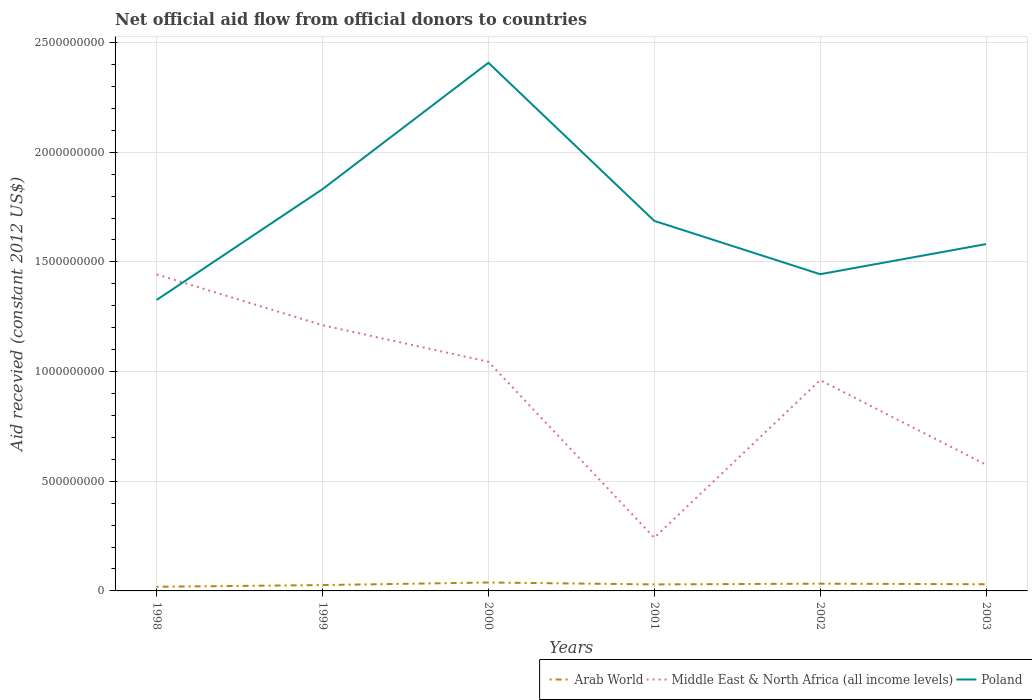How many different coloured lines are there?
Keep it short and to the point. 3. Does the line corresponding to Poland intersect with the line corresponding to Middle East & North Africa (all income levels)?
Keep it short and to the point. Yes. Is the number of lines equal to the number of legend labels?
Provide a short and direct response. Yes. Across all years, what is the maximum total aid received in Middle East & North Africa (all income levels)?
Give a very brief answer. 2.43e+08. What is the total total aid received in Poland in the graph?
Your response must be concise. 2.51e+08. What is the difference between the highest and the second highest total aid received in Arab World?
Your response must be concise. 1.94e+07. What is the difference between the highest and the lowest total aid received in Middle East & North Africa (all income levels)?
Offer a terse response. 4. Is the total aid received in Arab World strictly greater than the total aid received in Poland over the years?
Offer a terse response. Yes. How many lines are there?
Ensure brevity in your answer.  3. How many years are there in the graph?
Your answer should be very brief. 6. Are the values on the major ticks of Y-axis written in scientific E-notation?
Keep it short and to the point. No. Does the graph contain any zero values?
Offer a terse response. No. What is the title of the graph?
Your response must be concise. Net official aid flow from official donors to countries. Does "Denmark" appear as one of the legend labels in the graph?
Provide a succinct answer. No. What is the label or title of the Y-axis?
Give a very brief answer. Aid recevied (constant 2012 US$). What is the Aid recevied (constant 2012 US$) of Arab World in 1998?
Provide a short and direct response. 1.90e+07. What is the Aid recevied (constant 2012 US$) in Middle East & North Africa (all income levels) in 1998?
Provide a short and direct response. 1.44e+09. What is the Aid recevied (constant 2012 US$) of Poland in 1998?
Offer a very short reply. 1.33e+09. What is the Aid recevied (constant 2012 US$) of Arab World in 1999?
Keep it short and to the point. 2.67e+07. What is the Aid recevied (constant 2012 US$) of Middle East & North Africa (all income levels) in 1999?
Your answer should be very brief. 1.21e+09. What is the Aid recevied (constant 2012 US$) in Poland in 1999?
Provide a succinct answer. 1.83e+09. What is the Aid recevied (constant 2012 US$) of Arab World in 2000?
Your answer should be compact. 3.84e+07. What is the Aid recevied (constant 2012 US$) of Middle East & North Africa (all income levels) in 2000?
Offer a very short reply. 1.04e+09. What is the Aid recevied (constant 2012 US$) of Poland in 2000?
Offer a terse response. 2.41e+09. What is the Aid recevied (constant 2012 US$) in Arab World in 2001?
Your answer should be very brief. 2.97e+07. What is the Aid recevied (constant 2012 US$) in Middle East & North Africa (all income levels) in 2001?
Offer a terse response. 2.43e+08. What is the Aid recevied (constant 2012 US$) of Poland in 2001?
Ensure brevity in your answer.  1.69e+09. What is the Aid recevied (constant 2012 US$) of Arab World in 2002?
Ensure brevity in your answer.  3.30e+07. What is the Aid recevied (constant 2012 US$) of Middle East & North Africa (all income levels) in 2002?
Provide a short and direct response. 9.61e+08. What is the Aid recevied (constant 2012 US$) in Poland in 2002?
Your answer should be compact. 1.44e+09. What is the Aid recevied (constant 2012 US$) in Arab World in 2003?
Give a very brief answer. 3.05e+07. What is the Aid recevied (constant 2012 US$) of Middle East & North Africa (all income levels) in 2003?
Keep it short and to the point. 5.75e+08. What is the Aid recevied (constant 2012 US$) in Poland in 2003?
Offer a very short reply. 1.58e+09. Across all years, what is the maximum Aid recevied (constant 2012 US$) of Arab World?
Your answer should be very brief. 3.84e+07. Across all years, what is the maximum Aid recevied (constant 2012 US$) of Middle East & North Africa (all income levels)?
Provide a short and direct response. 1.44e+09. Across all years, what is the maximum Aid recevied (constant 2012 US$) of Poland?
Offer a terse response. 2.41e+09. Across all years, what is the minimum Aid recevied (constant 2012 US$) in Arab World?
Ensure brevity in your answer.  1.90e+07. Across all years, what is the minimum Aid recevied (constant 2012 US$) of Middle East & North Africa (all income levels)?
Your answer should be very brief. 2.43e+08. Across all years, what is the minimum Aid recevied (constant 2012 US$) of Poland?
Make the answer very short. 1.33e+09. What is the total Aid recevied (constant 2012 US$) of Arab World in the graph?
Offer a terse response. 1.77e+08. What is the total Aid recevied (constant 2012 US$) in Middle East & North Africa (all income levels) in the graph?
Keep it short and to the point. 5.48e+09. What is the total Aid recevied (constant 2012 US$) in Poland in the graph?
Your answer should be very brief. 1.03e+1. What is the difference between the Aid recevied (constant 2012 US$) in Arab World in 1998 and that in 1999?
Keep it short and to the point. -7.71e+06. What is the difference between the Aid recevied (constant 2012 US$) in Middle East & North Africa (all income levels) in 1998 and that in 1999?
Keep it short and to the point. 2.32e+08. What is the difference between the Aid recevied (constant 2012 US$) in Poland in 1998 and that in 1999?
Provide a succinct answer. -5.05e+08. What is the difference between the Aid recevied (constant 2012 US$) in Arab World in 1998 and that in 2000?
Give a very brief answer. -1.94e+07. What is the difference between the Aid recevied (constant 2012 US$) in Middle East & North Africa (all income levels) in 1998 and that in 2000?
Your answer should be compact. 3.98e+08. What is the difference between the Aid recevied (constant 2012 US$) in Poland in 1998 and that in 2000?
Provide a succinct answer. -1.08e+09. What is the difference between the Aid recevied (constant 2012 US$) in Arab World in 1998 and that in 2001?
Give a very brief answer. -1.07e+07. What is the difference between the Aid recevied (constant 2012 US$) in Middle East & North Africa (all income levels) in 1998 and that in 2001?
Keep it short and to the point. 1.20e+09. What is the difference between the Aid recevied (constant 2012 US$) of Poland in 1998 and that in 2001?
Offer a very short reply. -3.60e+08. What is the difference between the Aid recevied (constant 2012 US$) of Arab World in 1998 and that in 2002?
Keep it short and to the point. -1.41e+07. What is the difference between the Aid recevied (constant 2012 US$) in Middle East & North Africa (all income levels) in 1998 and that in 2002?
Give a very brief answer. 4.82e+08. What is the difference between the Aid recevied (constant 2012 US$) in Poland in 1998 and that in 2002?
Your answer should be compact. -1.17e+08. What is the difference between the Aid recevied (constant 2012 US$) of Arab World in 1998 and that in 2003?
Your answer should be compact. -1.15e+07. What is the difference between the Aid recevied (constant 2012 US$) of Middle East & North Africa (all income levels) in 1998 and that in 2003?
Your answer should be compact. 8.68e+08. What is the difference between the Aid recevied (constant 2012 US$) of Poland in 1998 and that in 2003?
Provide a succinct answer. -2.55e+08. What is the difference between the Aid recevied (constant 2012 US$) in Arab World in 1999 and that in 2000?
Your answer should be very brief. -1.17e+07. What is the difference between the Aid recevied (constant 2012 US$) in Middle East & North Africa (all income levels) in 1999 and that in 2000?
Give a very brief answer. 1.67e+08. What is the difference between the Aid recevied (constant 2012 US$) of Poland in 1999 and that in 2000?
Keep it short and to the point. -5.76e+08. What is the difference between the Aid recevied (constant 2012 US$) in Arab World in 1999 and that in 2001?
Provide a short and direct response. -3.03e+06. What is the difference between the Aid recevied (constant 2012 US$) in Middle East & North Africa (all income levels) in 1999 and that in 2001?
Provide a succinct answer. 9.69e+08. What is the difference between the Aid recevied (constant 2012 US$) of Poland in 1999 and that in 2001?
Your answer should be very brief. 1.45e+08. What is the difference between the Aid recevied (constant 2012 US$) in Arab World in 1999 and that in 2002?
Offer a very short reply. -6.38e+06. What is the difference between the Aid recevied (constant 2012 US$) in Middle East & North Africa (all income levels) in 1999 and that in 2002?
Your answer should be compact. 2.50e+08. What is the difference between the Aid recevied (constant 2012 US$) of Poland in 1999 and that in 2002?
Ensure brevity in your answer.  3.88e+08. What is the difference between the Aid recevied (constant 2012 US$) in Arab World in 1999 and that in 2003?
Give a very brief answer. -3.83e+06. What is the difference between the Aid recevied (constant 2012 US$) in Middle East & North Africa (all income levels) in 1999 and that in 2003?
Provide a succinct answer. 6.36e+08. What is the difference between the Aid recevied (constant 2012 US$) of Poland in 1999 and that in 2003?
Your answer should be very brief. 2.51e+08. What is the difference between the Aid recevied (constant 2012 US$) of Arab World in 2000 and that in 2001?
Your response must be concise. 8.66e+06. What is the difference between the Aid recevied (constant 2012 US$) of Middle East & North Africa (all income levels) in 2000 and that in 2001?
Your answer should be compact. 8.02e+08. What is the difference between the Aid recevied (constant 2012 US$) in Poland in 2000 and that in 2001?
Keep it short and to the point. 7.21e+08. What is the difference between the Aid recevied (constant 2012 US$) in Arab World in 2000 and that in 2002?
Keep it short and to the point. 5.31e+06. What is the difference between the Aid recevied (constant 2012 US$) of Middle East & North Africa (all income levels) in 2000 and that in 2002?
Your answer should be very brief. 8.36e+07. What is the difference between the Aid recevied (constant 2012 US$) of Poland in 2000 and that in 2002?
Make the answer very short. 9.64e+08. What is the difference between the Aid recevied (constant 2012 US$) in Arab World in 2000 and that in 2003?
Ensure brevity in your answer.  7.86e+06. What is the difference between the Aid recevied (constant 2012 US$) in Middle East & North Africa (all income levels) in 2000 and that in 2003?
Give a very brief answer. 4.69e+08. What is the difference between the Aid recevied (constant 2012 US$) of Poland in 2000 and that in 2003?
Offer a very short reply. 8.27e+08. What is the difference between the Aid recevied (constant 2012 US$) of Arab World in 2001 and that in 2002?
Your answer should be compact. -3.35e+06. What is the difference between the Aid recevied (constant 2012 US$) in Middle East & North Africa (all income levels) in 2001 and that in 2002?
Make the answer very short. -7.19e+08. What is the difference between the Aid recevied (constant 2012 US$) of Poland in 2001 and that in 2002?
Give a very brief answer. 2.43e+08. What is the difference between the Aid recevied (constant 2012 US$) of Arab World in 2001 and that in 2003?
Provide a short and direct response. -8.00e+05. What is the difference between the Aid recevied (constant 2012 US$) in Middle East & North Africa (all income levels) in 2001 and that in 2003?
Offer a terse response. -3.33e+08. What is the difference between the Aid recevied (constant 2012 US$) of Poland in 2001 and that in 2003?
Your response must be concise. 1.06e+08. What is the difference between the Aid recevied (constant 2012 US$) in Arab World in 2002 and that in 2003?
Give a very brief answer. 2.55e+06. What is the difference between the Aid recevied (constant 2012 US$) in Middle East & North Africa (all income levels) in 2002 and that in 2003?
Provide a short and direct response. 3.86e+08. What is the difference between the Aid recevied (constant 2012 US$) of Poland in 2002 and that in 2003?
Make the answer very short. -1.37e+08. What is the difference between the Aid recevied (constant 2012 US$) of Arab World in 1998 and the Aid recevied (constant 2012 US$) of Middle East & North Africa (all income levels) in 1999?
Ensure brevity in your answer.  -1.19e+09. What is the difference between the Aid recevied (constant 2012 US$) in Arab World in 1998 and the Aid recevied (constant 2012 US$) in Poland in 1999?
Your response must be concise. -1.81e+09. What is the difference between the Aid recevied (constant 2012 US$) in Middle East & North Africa (all income levels) in 1998 and the Aid recevied (constant 2012 US$) in Poland in 1999?
Make the answer very short. -3.89e+08. What is the difference between the Aid recevied (constant 2012 US$) of Arab World in 1998 and the Aid recevied (constant 2012 US$) of Middle East & North Africa (all income levels) in 2000?
Keep it short and to the point. -1.03e+09. What is the difference between the Aid recevied (constant 2012 US$) in Arab World in 1998 and the Aid recevied (constant 2012 US$) in Poland in 2000?
Make the answer very short. -2.39e+09. What is the difference between the Aid recevied (constant 2012 US$) in Middle East & North Africa (all income levels) in 1998 and the Aid recevied (constant 2012 US$) in Poland in 2000?
Provide a succinct answer. -9.65e+08. What is the difference between the Aid recevied (constant 2012 US$) in Arab World in 1998 and the Aid recevied (constant 2012 US$) in Middle East & North Africa (all income levels) in 2001?
Ensure brevity in your answer.  -2.24e+08. What is the difference between the Aid recevied (constant 2012 US$) of Arab World in 1998 and the Aid recevied (constant 2012 US$) of Poland in 2001?
Provide a succinct answer. -1.67e+09. What is the difference between the Aid recevied (constant 2012 US$) in Middle East & North Africa (all income levels) in 1998 and the Aid recevied (constant 2012 US$) in Poland in 2001?
Offer a terse response. -2.44e+08. What is the difference between the Aid recevied (constant 2012 US$) in Arab World in 1998 and the Aid recevied (constant 2012 US$) in Middle East & North Africa (all income levels) in 2002?
Keep it short and to the point. -9.42e+08. What is the difference between the Aid recevied (constant 2012 US$) in Arab World in 1998 and the Aid recevied (constant 2012 US$) in Poland in 2002?
Give a very brief answer. -1.42e+09. What is the difference between the Aid recevied (constant 2012 US$) of Middle East & North Africa (all income levels) in 1998 and the Aid recevied (constant 2012 US$) of Poland in 2002?
Your response must be concise. -8.70e+05. What is the difference between the Aid recevied (constant 2012 US$) in Arab World in 1998 and the Aid recevied (constant 2012 US$) in Middle East & North Africa (all income levels) in 2003?
Give a very brief answer. -5.56e+08. What is the difference between the Aid recevied (constant 2012 US$) in Arab World in 1998 and the Aid recevied (constant 2012 US$) in Poland in 2003?
Provide a short and direct response. -1.56e+09. What is the difference between the Aid recevied (constant 2012 US$) of Middle East & North Africa (all income levels) in 1998 and the Aid recevied (constant 2012 US$) of Poland in 2003?
Keep it short and to the point. -1.38e+08. What is the difference between the Aid recevied (constant 2012 US$) of Arab World in 1999 and the Aid recevied (constant 2012 US$) of Middle East & North Africa (all income levels) in 2000?
Your answer should be compact. -1.02e+09. What is the difference between the Aid recevied (constant 2012 US$) of Arab World in 1999 and the Aid recevied (constant 2012 US$) of Poland in 2000?
Keep it short and to the point. -2.38e+09. What is the difference between the Aid recevied (constant 2012 US$) of Middle East & North Africa (all income levels) in 1999 and the Aid recevied (constant 2012 US$) of Poland in 2000?
Offer a terse response. -1.20e+09. What is the difference between the Aid recevied (constant 2012 US$) in Arab World in 1999 and the Aid recevied (constant 2012 US$) in Middle East & North Africa (all income levels) in 2001?
Provide a succinct answer. -2.16e+08. What is the difference between the Aid recevied (constant 2012 US$) in Arab World in 1999 and the Aid recevied (constant 2012 US$) in Poland in 2001?
Offer a very short reply. -1.66e+09. What is the difference between the Aid recevied (constant 2012 US$) of Middle East & North Africa (all income levels) in 1999 and the Aid recevied (constant 2012 US$) of Poland in 2001?
Offer a very short reply. -4.76e+08. What is the difference between the Aid recevied (constant 2012 US$) in Arab World in 1999 and the Aid recevied (constant 2012 US$) in Middle East & North Africa (all income levels) in 2002?
Provide a short and direct response. -9.35e+08. What is the difference between the Aid recevied (constant 2012 US$) in Arab World in 1999 and the Aid recevied (constant 2012 US$) in Poland in 2002?
Make the answer very short. -1.42e+09. What is the difference between the Aid recevied (constant 2012 US$) in Middle East & North Africa (all income levels) in 1999 and the Aid recevied (constant 2012 US$) in Poland in 2002?
Ensure brevity in your answer.  -2.33e+08. What is the difference between the Aid recevied (constant 2012 US$) of Arab World in 1999 and the Aid recevied (constant 2012 US$) of Middle East & North Africa (all income levels) in 2003?
Make the answer very short. -5.49e+08. What is the difference between the Aid recevied (constant 2012 US$) in Arab World in 1999 and the Aid recevied (constant 2012 US$) in Poland in 2003?
Make the answer very short. -1.55e+09. What is the difference between the Aid recevied (constant 2012 US$) of Middle East & North Africa (all income levels) in 1999 and the Aid recevied (constant 2012 US$) of Poland in 2003?
Provide a succinct answer. -3.70e+08. What is the difference between the Aid recevied (constant 2012 US$) in Arab World in 2000 and the Aid recevied (constant 2012 US$) in Middle East & North Africa (all income levels) in 2001?
Your answer should be very brief. -2.04e+08. What is the difference between the Aid recevied (constant 2012 US$) of Arab World in 2000 and the Aid recevied (constant 2012 US$) of Poland in 2001?
Your answer should be very brief. -1.65e+09. What is the difference between the Aid recevied (constant 2012 US$) in Middle East & North Africa (all income levels) in 2000 and the Aid recevied (constant 2012 US$) in Poland in 2001?
Keep it short and to the point. -6.42e+08. What is the difference between the Aid recevied (constant 2012 US$) of Arab World in 2000 and the Aid recevied (constant 2012 US$) of Middle East & North Africa (all income levels) in 2002?
Your answer should be compact. -9.23e+08. What is the difference between the Aid recevied (constant 2012 US$) of Arab World in 2000 and the Aid recevied (constant 2012 US$) of Poland in 2002?
Your answer should be compact. -1.41e+09. What is the difference between the Aid recevied (constant 2012 US$) in Middle East & North Africa (all income levels) in 2000 and the Aid recevied (constant 2012 US$) in Poland in 2002?
Provide a succinct answer. -3.99e+08. What is the difference between the Aid recevied (constant 2012 US$) in Arab World in 2000 and the Aid recevied (constant 2012 US$) in Middle East & North Africa (all income levels) in 2003?
Offer a terse response. -5.37e+08. What is the difference between the Aid recevied (constant 2012 US$) in Arab World in 2000 and the Aid recevied (constant 2012 US$) in Poland in 2003?
Your response must be concise. -1.54e+09. What is the difference between the Aid recevied (constant 2012 US$) in Middle East & North Africa (all income levels) in 2000 and the Aid recevied (constant 2012 US$) in Poland in 2003?
Your response must be concise. -5.36e+08. What is the difference between the Aid recevied (constant 2012 US$) in Arab World in 2001 and the Aid recevied (constant 2012 US$) in Middle East & North Africa (all income levels) in 2002?
Offer a terse response. -9.31e+08. What is the difference between the Aid recevied (constant 2012 US$) in Arab World in 2001 and the Aid recevied (constant 2012 US$) in Poland in 2002?
Your response must be concise. -1.41e+09. What is the difference between the Aid recevied (constant 2012 US$) in Middle East & North Africa (all income levels) in 2001 and the Aid recevied (constant 2012 US$) in Poland in 2002?
Offer a very short reply. -1.20e+09. What is the difference between the Aid recevied (constant 2012 US$) of Arab World in 2001 and the Aid recevied (constant 2012 US$) of Middle East & North Africa (all income levels) in 2003?
Ensure brevity in your answer.  -5.46e+08. What is the difference between the Aid recevied (constant 2012 US$) in Arab World in 2001 and the Aid recevied (constant 2012 US$) in Poland in 2003?
Give a very brief answer. -1.55e+09. What is the difference between the Aid recevied (constant 2012 US$) in Middle East & North Africa (all income levels) in 2001 and the Aid recevied (constant 2012 US$) in Poland in 2003?
Offer a very short reply. -1.34e+09. What is the difference between the Aid recevied (constant 2012 US$) of Arab World in 2002 and the Aid recevied (constant 2012 US$) of Middle East & North Africa (all income levels) in 2003?
Your answer should be very brief. -5.42e+08. What is the difference between the Aid recevied (constant 2012 US$) of Arab World in 2002 and the Aid recevied (constant 2012 US$) of Poland in 2003?
Ensure brevity in your answer.  -1.55e+09. What is the difference between the Aid recevied (constant 2012 US$) in Middle East & North Africa (all income levels) in 2002 and the Aid recevied (constant 2012 US$) in Poland in 2003?
Your answer should be very brief. -6.20e+08. What is the average Aid recevied (constant 2012 US$) in Arab World per year?
Your response must be concise. 2.95e+07. What is the average Aid recevied (constant 2012 US$) in Middle East & North Africa (all income levels) per year?
Offer a terse response. 9.13e+08. What is the average Aid recevied (constant 2012 US$) in Poland per year?
Ensure brevity in your answer.  1.71e+09. In the year 1998, what is the difference between the Aid recevied (constant 2012 US$) of Arab World and Aid recevied (constant 2012 US$) of Middle East & North Africa (all income levels)?
Keep it short and to the point. -1.42e+09. In the year 1998, what is the difference between the Aid recevied (constant 2012 US$) in Arab World and Aid recevied (constant 2012 US$) in Poland?
Your answer should be very brief. -1.31e+09. In the year 1998, what is the difference between the Aid recevied (constant 2012 US$) of Middle East & North Africa (all income levels) and Aid recevied (constant 2012 US$) of Poland?
Offer a very short reply. 1.16e+08. In the year 1999, what is the difference between the Aid recevied (constant 2012 US$) in Arab World and Aid recevied (constant 2012 US$) in Middle East & North Africa (all income levels)?
Your answer should be compact. -1.18e+09. In the year 1999, what is the difference between the Aid recevied (constant 2012 US$) in Arab World and Aid recevied (constant 2012 US$) in Poland?
Ensure brevity in your answer.  -1.81e+09. In the year 1999, what is the difference between the Aid recevied (constant 2012 US$) of Middle East & North Africa (all income levels) and Aid recevied (constant 2012 US$) of Poland?
Provide a succinct answer. -6.20e+08. In the year 2000, what is the difference between the Aid recevied (constant 2012 US$) of Arab World and Aid recevied (constant 2012 US$) of Middle East & North Africa (all income levels)?
Offer a very short reply. -1.01e+09. In the year 2000, what is the difference between the Aid recevied (constant 2012 US$) in Arab World and Aid recevied (constant 2012 US$) in Poland?
Give a very brief answer. -2.37e+09. In the year 2000, what is the difference between the Aid recevied (constant 2012 US$) of Middle East & North Africa (all income levels) and Aid recevied (constant 2012 US$) of Poland?
Give a very brief answer. -1.36e+09. In the year 2001, what is the difference between the Aid recevied (constant 2012 US$) in Arab World and Aid recevied (constant 2012 US$) in Middle East & North Africa (all income levels)?
Your answer should be very brief. -2.13e+08. In the year 2001, what is the difference between the Aid recevied (constant 2012 US$) in Arab World and Aid recevied (constant 2012 US$) in Poland?
Your answer should be compact. -1.66e+09. In the year 2001, what is the difference between the Aid recevied (constant 2012 US$) in Middle East & North Africa (all income levels) and Aid recevied (constant 2012 US$) in Poland?
Provide a succinct answer. -1.44e+09. In the year 2002, what is the difference between the Aid recevied (constant 2012 US$) in Arab World and Aid recevied (constant 2012 US$) in Middle East & North Africa (all income levels)?
Your answer should be compact. -9.28e+08. In the year 2002, what is the difference between the Aid recevied (constant 2012 US$) in Arab World and Aid recevied (constant 2012 US$) in Poland?
Provide a short and direct response. -1.41e+09. In the year 2002, what is the difference between the Aid recevied (constant 2012 US$) of Middle East & North Africa (all income levels) and Aid recevied (constant 2012 US$) of Poland?
Offer a very short reply. -4.83e+08. In the year 2003, what is the difference between the Aid recevied (constant 2012 US$) of Arab World and Aid recevied (constant 2012 US$) of Middle East & North Africa (all income levels)?
Provide a succinct answer. -5.45e+08. In the year 2003, what is the difference between the Aid recevied (constant 2012 US$) of Arab World and Aid recevied (constant 2012 US$) of Poland?
Your answer should be very brief. -1.55e+09. In the year 2003, what is the difference between the Aid recevied (constant 2012 US$) of Middle East & North Africa (all income levels) and Aid recevied (constant 2012 US$) of Poland?
Provide a short and direct response. -1.01e+09. What is the ratio of the Aid recevied (constant 2012 US$) of Arab World in 1998 to that in 1999?
Your response must be concise. 0.71. What is the ratio of the Aid recevied (constant 2012 US$) in Middle East & North Africa (all income levels) in 1998 to that in 1999?
Provide a short and direct response. 1.19. What is the ratio of the Aid recevied (constant 2012 US$) in Poland in 1998 to that in 1999?
Make the answer very short. 0.72. What is the ratio of the Aid recevied (constant 2012 US$) of Arab World in 1998 to that in 2000?
Provide a short and direct response. 0.49. What is the ratio of the Aid recevied (constant 2012 US$) of Middle East & North Africa (all income levels) in 1998 to that in 2000?
Provide a short and direct response. 1.38. What is the ratio of the Aid recevied (constant 2012 US$) in Poland in 1998 to that in 2000?
Offer a terse response. 0.55. What is the ratio of the Aid recevied (constant 2012 US$) of Arab World in 1998 to that in 2001?
Your response must be concise. 0.64. What is the ratio of the Aid recevied (constant 2012 US$) in Middle East & North Africa (all income levels) in 1998 to that in 2001?
Your answer should be very brief. 5.95. What is the ratio of the Aid recevied (constant 2012 US$) of Poland in 1998 to that in 2001?
Your answer should be compact. 0.79. What is the ratio of the Aid recevied (constant 2012 US$) in Arab World in 1998 to that in 2002?
Ensure brevity in your answer.  0.57. What is the ratio of the Aid recevied (constant 2012 US$) in Middle East & North Africa (all income levels) in 1998 to that in 2002?
Ensure brevity in your answer.  1.5. What is the ratio of the Aid recevied (constant 2012 US$) in Poland in 1998 to that in 2002?
Your response must be concise. 0.92. What is the ratio of the Aid recevied (constant 2012 US$) of Arab World in 1998 to that in 2003?
Ensure brevity in your answer.  0.62. What is the ratio of the Aid recevied (constant 2012 US$) of Middle East & North Africa (all income levels) in 1998 to that in 2003?
Give a very brief answer. 2.51. What is the ratio of the Aid recevied (constant 2012 US$) in Poland in 1998 to that in 2003?
Offer a very short reply. 0.84. What is the ratio of the Aid recevied (constant 2012 US$) of Arab World in 1999 to that in 2000?
Your response must be concise. 0.7. What is the ratio of the Aid recevied (constant 2012 US$) of Middle East & North Africa (all income levels) in 1999 to that in 2000?
Offer a terse response. 1.16. What is the ratio of the Aid recevied (constant 2012 US$) in Poland in 1999 to that in 2000?
Provide a short and direct response. 0.76. What is the ratio of the Aid recevied (constant 2012 US$) in Arab World in 1999 to that in 2001?
Your response must be concise. 0.9. What is the ratio of the Aid recevied (constant 2012 US$) in Middle East & North Africa (all income levels) in 1999 to that in 2001?
Your answer should be very brief. 4.99. What is the ratio of the Aid recevied (constant 2012 US$) in Poland in 1999 to that in 2001?
Keep it short and to the point. 1.09. What is the ratio of the Aid recevied (constant 2012 US$) of Arab World in 1999 to that in 2002?
Provide a short and direct response. 0.81. What is the ratio of the Aid recevied (constant 2012 US$) of Middle East & North Africa (all income levels) in 1999 to that in 2002?
Provide a short and direct response. 1.26. What is the ratio of the Aid recevied (constant 2012 US$) of Poland in 1999 to that in 2002?
Provide a short and direct response. 1.27. What is the ratio of the Aid recevied (constant 2012 US$) of Arab World in 1999 to that in 2003?
Your answer should be very brief. 0.87. What is the ratio of the Aid recevied (constant 2012 US$) of Middle East & North Africa (all income levels) in 1999 to that in 2003?
Your answer should be very brief. 2.11. What is the ratio of the Aid recevied (constant 2012 US$) of Poland in 1999 to that in 2003?
Offer a very short reply. 1.16. What is the ratio of the Aid recevied (constant 2012 US$) of Arab World in 2000 to that in 2001?
Provide a short and direct response. 1.29. What is the ratio of the Aid recevied (constant 2012 US$) of Middle East & North Africa (all income levels) in 2000 to that in 2001?
Provide a short and direct response. 4.31. What is the ratio of the Aid recevied (constant 2012 US$) of Poland in 2000 to that in 2001?
Your answer should be compact. 1.43. What is the ratio of the Aid recevied (constant 2012 US$) in Arab World in 2000 to that in 2002?
Make the answer very short. 1.16. What is the ratio of the Aid recevied (constant 2012 US$) of Middle East & North Africa (all income levels) in 2000 to that in 2002?
Give a very brief answer. 1.09. What is the ratio of the Aid recevied (constant 2012 US$) in Poland in 2000 to that in 2002?
Your answer should be very brief. 1.67. What is the ratio of the Aid recevied (constant 2012 US$) in Arab World in 2000 to that in 2003?
Offer a very short reply. 1.26. What is the ratio of the Aid recevied (constant 2012 US$) in Middle East & North Africa (all income levels) in 2000 to that in 2003?
Your response must be concise. 1.82. What is the ratio of the Aid recevied (constant 2012 US$) of Poland in 2000 to that in 2003?
Your answer should be very brief. 1.52. What is the ratio of the Aid recevied (constant 2012 US$) of Arab World in 2001 to that in 2002?
Make the answer very short. 0.9. What is the ratio of the Aid recevied (constant 2012 US$) of Middle East & North Africa (all income levels) in 2001 to that in 2002?
Provide a succinct answer. 0.25. What is the ratio of the Aid recevied (constant 2012 US$) of Poland in 2001 to that in 2002?
Give a very brief answer. 1.17. What is the ratio of the Aid recevied (constant 2012 US$) of Arab World in 2001 to that in 2003?
Your response must be concise. 0.97. What is the ratio of the Aid recevied (constant 2012 US$) in Middle East & North Africa (all income levels) in 2001 to that in 2003?
Your response must be concise. 0.42. What is the ratio of the Aid recevied (constant 2012 US$) of Poland in 2001 to that in 2003?
Give a very brief answer. 1.07. What is the ratio of the Aid recevied (constant 2012 US$) in Arab World in 2002 to that in 2003?
Offer a terse response. 1.08. What is the ratio of the Aid recevied (constant 2012 US$) in Middle East & North Africa (all income levels) in 2002 to that in 2003?
Give a very brief answer. 1.67. What is the ratio of the Aid recevied (constant 2012 US$) of Poland in 2002 to that in 2003?
Offer a very short reply. 0.91. What is the difference between the highest and the second highest Aid recevied (constant 2012 US$) of Arab World?
Offer a terse response. 5.31e+06. What is the difference between the highest and the second highest Aid recevied (constant 2012 US$) of Middle East & North Africa (all income levels)?
Your response must be concise. 2.32e+08. What is the difference between the highest and the second highest Aid recevied (constant 2012 US$) of Poland?
Offer a very short reply. 5.76e+08. What is the difference between the highest and the lowest Aid recevied (constant 2012 US$) in Arab World?
Keep it short and to the point. 1.94e+07. What is the difference between the highest and the lowest Aid recevied (constant 2012 US$) in Middle East & North Africa (all income levels)?
Your answer should be very brief. 1.20e+09. What is the difference between the highest and the lowest Aid recevied (constant 2012 US$) in Poland?
Ensure brevity in your answer.  1.08e+09. 